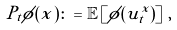<formula> <loc_0><loc_0><loc_500><loc_500>P _ { t } \phi ( x ) \colon = \mathbb { E } \left [ \phi ( u ^ { x } _ { t } ) \right ] \, ,</formula> 